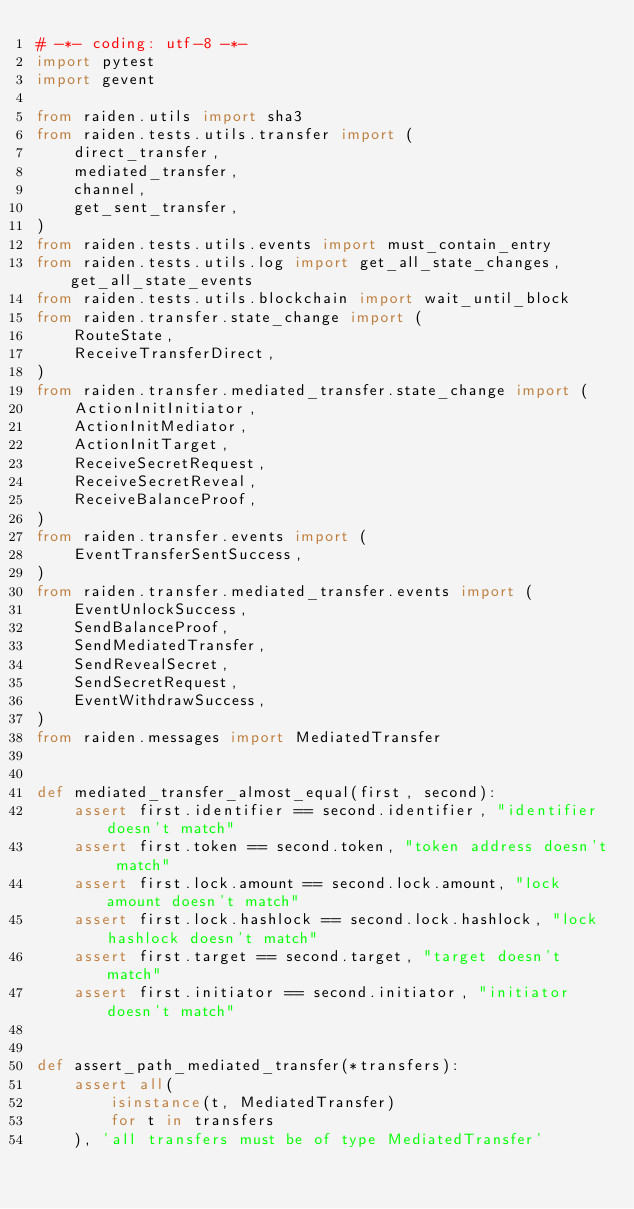Convert code to text. <code><loc_0><loc_0><loc_500><loc_500><_Python_># -*- coding: utf-8 -*-
import pytest
import gevent

from raiden.utils import sha3
from raiden.tests.utils.transfer import (
    direct_transfer,
    mediated_transfer,
    channel,
    get_sent_transfer,
)
from raiden.tests.utils.events import must_contain_entry
from raiden.tests.utils.log import get_all_state_changes, get_all_state_events
from raiden.tests.utils.blockchain import wait_until_block
from raiden.transfer.state_change import (
    RouteState,
    ReceiveTransferDirect,
)
from raiden.transfer.mediated_transfer.state_change import (
    ActionInitInitiator,
    ActionInitMediator,
    ActionInitTarget,
    ReceiveSecretRequest,
    ReceiveSecretReveal,
    ReceiveBalanceProof,
)
from raiden.transfer.events import (
    EventTransferSentSuccess,
)
from raiden.transfer.mediated_transfer.events import (
    EventUnlockSuccess,
    SendBalanceProof,
    SendMediatedTransfer,
    SendRevealSecret,
    SendSecretRequest,
    EventWithdrawSuccess,
)
from raiden.messages import MediatedTransfer


def mediated_transfer_almost_equal(first, second):
    assert first.identifier == second.identifier, "identifier doesn't match"
    assert first.token == second.token, "token address doesn't match"
    assert first.lock.amount == second.lock.amount, "lock amount doesn't match"
    assert first.lock.hashlock == second.lock.hashlock, "lock hashlock doesn't match"
    assert first.target == second.target, "target doesn't match"
    assert first.initiator == second.initiator, "initiator doesn't match"


def assert_path_mediated_transfer(*transfers):
    assert all(
        isinstance(t, MediatedTransfer)
        for t in transfers
    ), 'all transfers must be of type MediatedTransfer'
</code> 